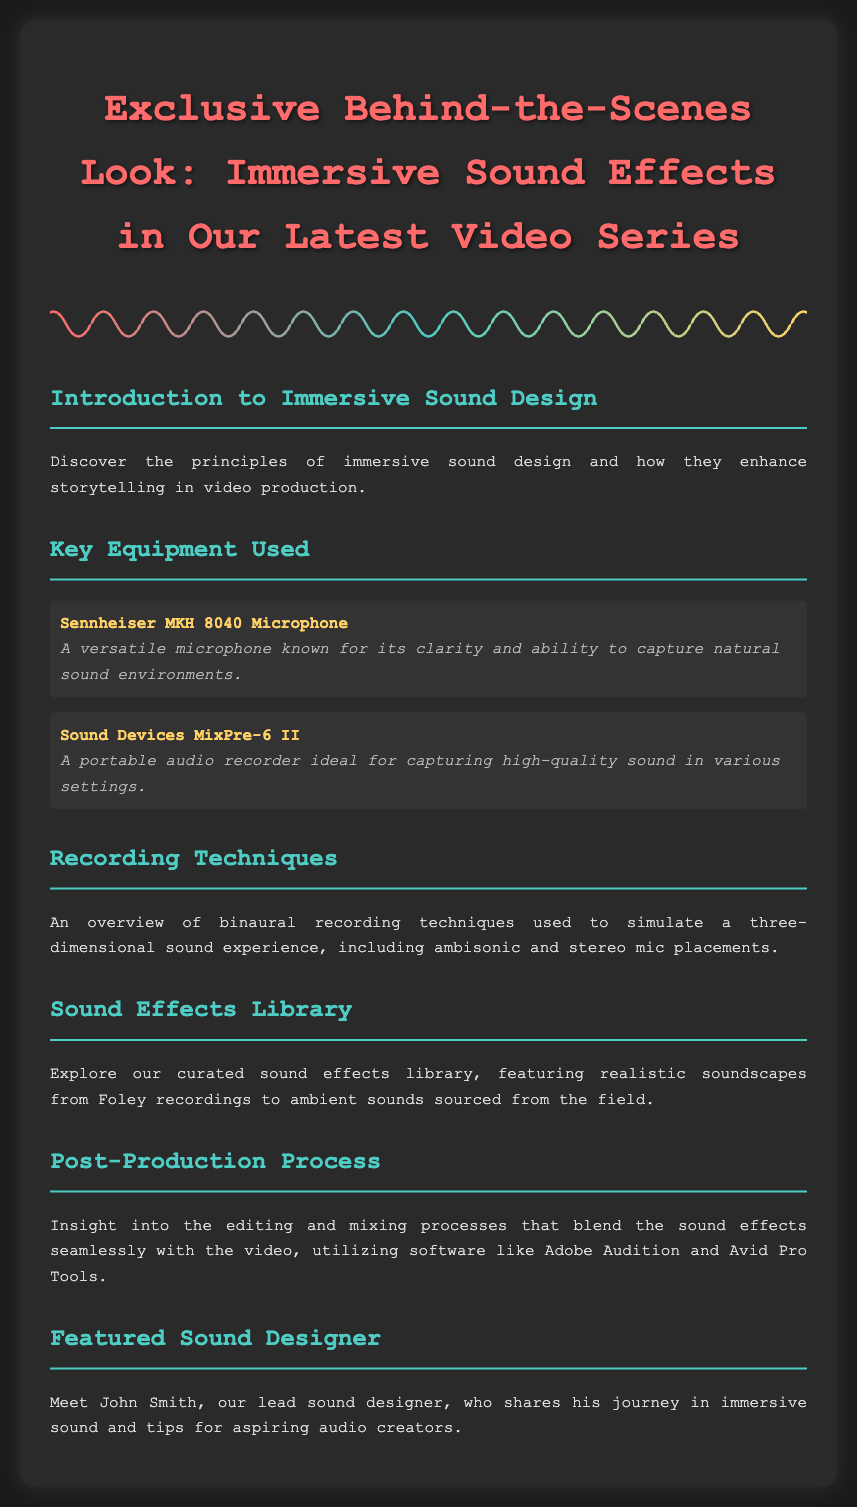What is the title of the document? The title of the document is provided in the heading, which indicates the topic of the content.
Answer: Exclusive Behind-the-Scenes Look: Immersive Sound Effects in Our Latest Video Series Who is the featured sound designer? The document specifically mentions the name of the lead sound designer who is featured in the content.
Answer: John Smith How many microphones are listed in the key equipment used? The number of microphones is directly stated in the list of key equipment presented in the document.
Answer: One What type of recording techniques are overviewed? The document summarizes specific techniques related to sound recording that are utilized in the sound design process.
Answer: Binaural recording techniques What software is mentioned in the post-production process? The editing and mixing processes refer to specific software used in the post-production described in the document.
Answer: Adobe Audition and Avid Pro Tools What is the purpose of immersive sound design? The introduction section succinctly describes the main goal of using immersive sound design in video production.
Answer: Enhance storytelling What is the description of the Sennheiser MKH 8040 Microphone? The document provides a brief explanation of this specific piece of equipment and its qualities.
Answer: A versatile microphone known for its clarity and ability to capture natural sound environments 